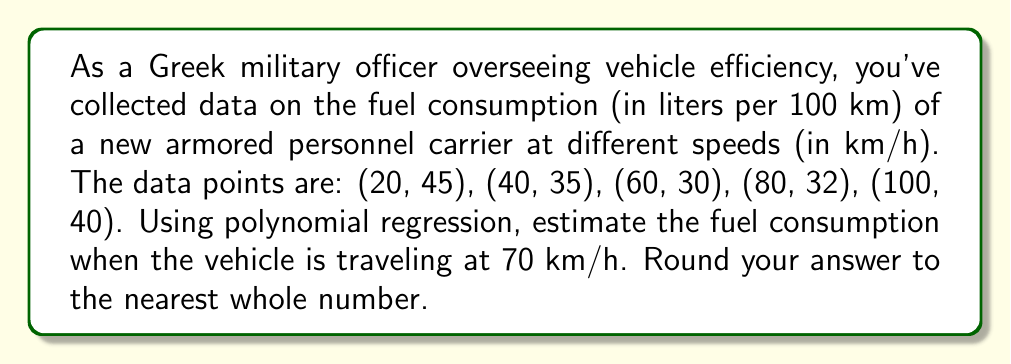Provide a solution to this math problem. 1) Given the shape of the data, we'll use a quadratic polynomial regression model: $y = ax^2 + bx + c$, where $y$ is fuel consumption and $x$ is speed.

2) To find the coefficients $a$, $b$, and $c$, we'll use a system of normal equations:

   $$\begin{cases}
   \sum y = an\sum x^2 + b\sum x + nc \\
   \sum xy = a\sum x^3 + b\sum x^2 + c\sum x \\
   \sum x^2y = a\sum x^4 + b\sum x^3 + c\sum x^2
   \end{cases}$$

3) Calculate the sums:
   $\sum x = 300$, $\sum y = 182$, $\sum x^2 = 24000$, $\sum x^3 = 2240000$
   $\sum x^4 = 220000000$, $\sum xy = 11400$, $\sum x^2y = 1060000$

4) Substitute into the system of equations:

   $$\begin{cases}
   182 = 24000a + 300b + 5c \\
   11400 = 2240000a + 24000b + 300c \\
   1060000 = 220000000a + 2240000b + 24000c
   \end{cases}$$

5) Solve this system (using a calculator or computer algebra system) to get:
   $a \approx 0.00425$, $b \approx -0.5425$, $c \approx 54.625$

6) Our quadratic model is thus:
   $y = 0.00425x^2 - 0.5425x + 54.625$

7) To estimate fuel consumption at 70 km/h, substitute $x = 70$:
   $y = 0.00425(70)^2 - 0.5425(70) + 54.625 \approx 30.8$

8) Rounding to the nearest whole number: 31
Answer: 31 liters per 100 km 